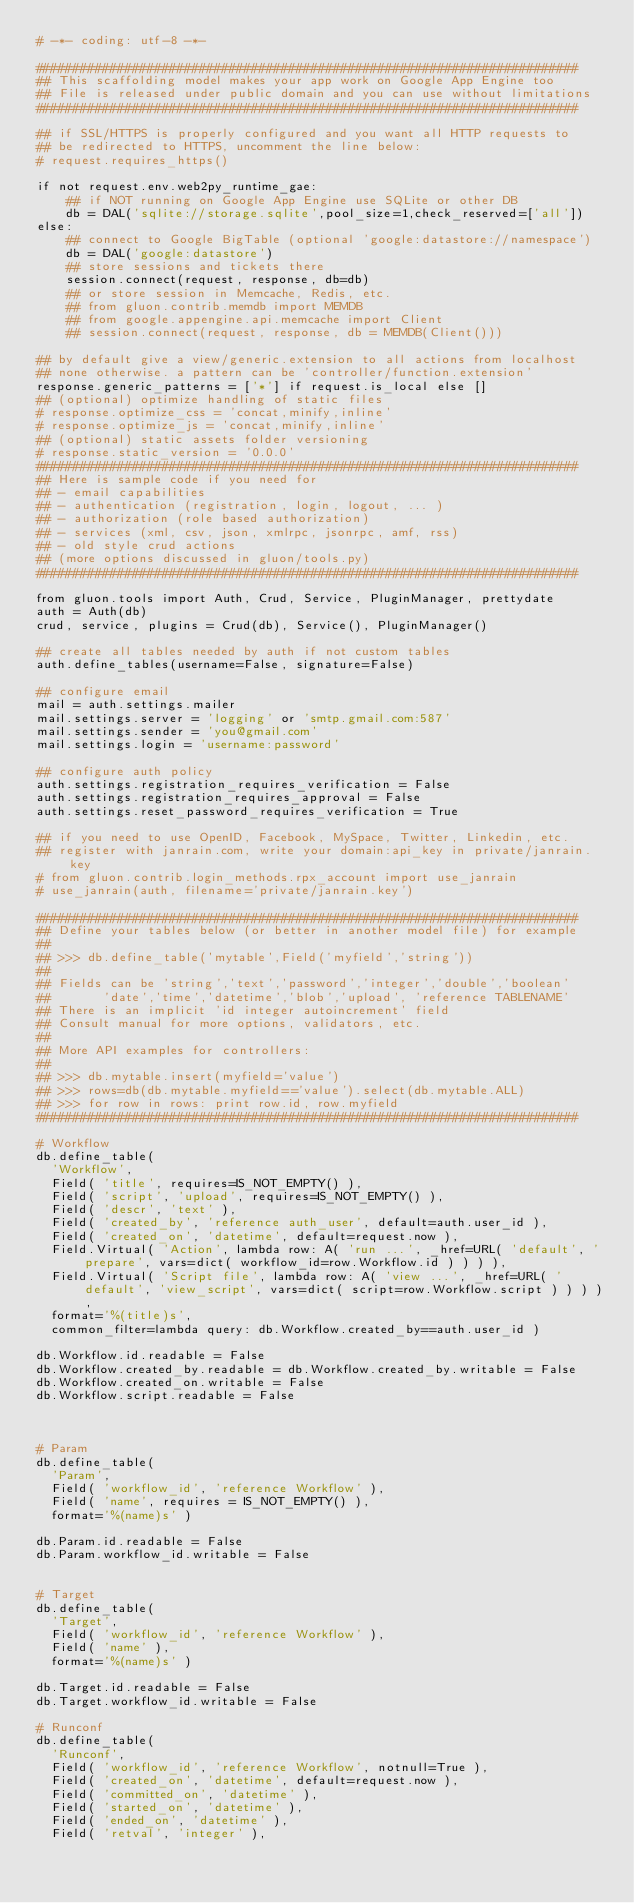Convert code to text. <code><loc_0><loc_0><loc_500><loc_500><_Python_># -*- coding: utf-8 -*-

#########################################################################
## This scaffolding model makes your app work on Google App Engine too
## File is released under public domain and you can use without limitations
#########################################################################

## if SSL/HTTPS is properly configured and you want all HTTP requests to
## be redirected to HTTPS, uncomment the line below:
# request.requires_https()

if not request.env.web2py_runtime_gae:
    ## if NOT running on Google App Engine use SQLite or other DB
    db = DAL('sqlite://storage.sqlite',pool_size=1,check_reserved=['all'])
else:
    ## connect to Google BigTable (optional 'google:datastore://namespace')
    db = DAL('google:datastore')
    ## store sessions and tickets there
    session.connect(request, response, db=db)
    ## or store session in Memcache, Redis, etc.
    ## from gluon.contrib.memdb import MEMDB
    ## from google.appengine.api.memcache import Client
    ## session.connect(request, response, db = MEMDB(Client()))

## by default give a view/generic.extension to all actions from localhost
## none otherwise. a pattern can be 'controller/function.extension'
response.generic_patterns = ['*'] if request.is_local else []
## (optional) optimize handling of static files
# response.optimize_css = 'concat,minify,inline'
# response.optimize_js = 'concat,minify,inline'
## (optional) static assets folder versioning
# response.static_version = '0.0.0'
#########################################################################
## Here is sample code if you need for
## - email capabilities
## - authentication (registration, login, logout, ... )
## - authorization (role based authorization)
## - services (xml, csv, json, xmlrpc, jsonrpc, amf, rss)
## - old style crud actions
## (more options discussed in gluon/tools.py)
#########################################################################

from gluon.tools import Auth, Crud, Service, PluginManager, prettydate
auth = Auth(db)
crud, service, plugins = Crud(db), Service(), PluginManager()

## create all tables needed by auth if not custom tables
auth.define_tables(username=False, signature=False)

## configure email
mail = auth.settings.mailer
mail.settings.server = 'logging' or 'smtp.gmail.com:587'
mail.settings.sender = 'you@gmail.com'
mail.settings.login = 'username:password'

## configure auth policy
auth.settings.registration_requires_verification = False
auth.settings.registration_requires_approval = False
auth.settings.reset_password_requires_verification = True

## if you need to use OpenID, Facebook, MySpace, Twitter, Linkedin, etc.
## register with janrain.com, write your domain:api_key in private/janrain.key
# from gluon.contrib.login_methods.rpx_account import use_janrain
# use_janrain(auth, filename='private/janrain.key')

#########################################################################
## Define your tables below (or better in another model file) for example
##
## >>> db.define_table('mytable',Field('myfield','string'))
##
## Fields can be 'string','text','password','integer','double','boolean'
##       'date','time','datetime','blob','upload', 'reference TABLENAME'
## There is an implicit 'id integer autoincrement' field
## Consult manual for more options, validators, etc.
##
## More API examples for controllers:
##
## >>> db.mytable.insert(myfield='value')
## >>> rows=db(db.mytable.myfield=='value').select(db.mytable.ALL)
## >>> for row in rows: print row.id, row.myfield
#########################################################################

# Workflow
db.define_table(
  'Workflow',
  Field( 'title', requires=IS_NOT_EMPTY() ),
  Field( 'script', 'upload', requires=IS_NOT_EMPTY() ),
  Field( 'descr', 'text' ),
  Field( 'created_by', 'reference auth_user', default=auth.user_id ),
  Field( 'created_on', 'datetime', default=request.now ),
  Field.Virtual( 'Action', lambda row: A( 'run ...', _href=URL( 'default', 'prepare', vars=dict( workflow_id=row.Workflow.id ) ) ) ),
  Field.Virtual( 'Script file', lambda row: A( 'view ...', _href=URL( 'default', 'view_script', vars=dict( script=row.Workflow.script ) ) ) ),
  format='%(title)s',
  common_filter=lambda query: db.Workflow.created_by==auth.user_id )

db.Workflow.id.readable = False
db.Workflow.created_by.readable = db.Workflow.created_by.writable = False
db.Workflow.created_on.writable = False
db.Workflow.script.readable = False



# Param
db.define_table(
  'Param',
  Field( 'workflow_id', 'reference Workflow' ),
  Field( 'name', requires = IS_NOT_EMPTY() ),
  format='%(name)s' )

db.Param.id.readable = False
db.Param.workflow_id.writable = False


# Target
db.define_table(
  'Target',
  Field( 'workflow_id', 'reference Workflow' ),
  Field( 'name' ),
  format='%(name)s' )

db.Target.id.readable = False
db.Target.workflow_id.writable = False

# Runconf
db.define_table(
  'Runconf',
  Field( 'workflow_id', 'reference Workflow', notnull=True ),
  Field( 'created_on', 'datetime', default=request.now ),
  Field( 'committed_on', 'datetime' ),
  Field( 'started_on', 'datetime' ),
  Field( 'ended_on', 'datetime' ),
  Field( 'retval', 'integer' ),</code> 